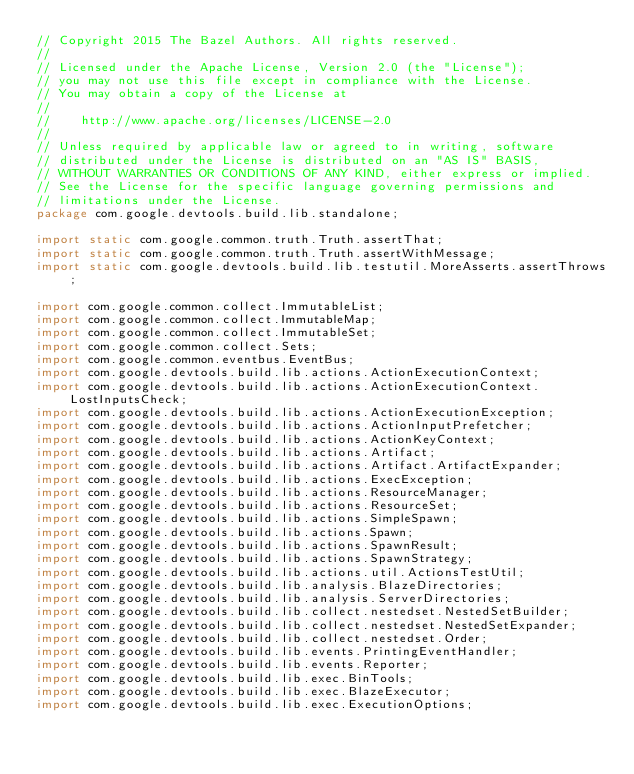Convert code to text. <code><loc_0><loc_0><loc_500><loc_500><_Java_>// Copyright 2015 The Bazel Authors. All rights reserved.
//
// Licensed under the Apache License, Version 2.0 (the "License");
// you may not use this file except in compliance with the License.
// You may obtain a copy of the License at
//
//    http://www.apache.org/licenses/LICENSE-2.0
//
// Unless required by applicable law or agreed to in writing, software
// distributed under the License is distributed on an "AS IS" BASIS,
// WITHOUT WARRANTIES OR CONDITIONS OF ANY KIND, either express or implied.
// See the License for the specific language governing permissions and
// limitations under the License.
package com.google.devtools.build.lib.standalone;

import static com.google.common.truth.Truth.assertThat;
import static com.google.common.truth.Truth.assertWithMessage;
import static com.google.devtools.build.lib.testutil.MoreAsserts.assertThrows;

import com.google.common.collect.ImmutableList;
import com.google.common.collect.ImmutableMap;
import com.google.common.collect.ImmutableSet;
import com.google.common.collect.Sets;
import com.google.common.eventbus.EventBus;
import com.google.devtools.build.lib.actions.ActionExecutionContext;
import com.google.devtools.build.lib.actions.ActionExecutionContext.LostInputsCheck;
import com.google.devtools.build.lib.actions.ActionExecutionException;
import com.google.devtools.build.lib.actions.ActionInputPrefetcher;
import com.google.devtools.build.lib.actions.ActionKeyContext;
import com.google.devtools.build.lib.actions.Artifact;
import com.google.devtools.build.lib.actions.Artifact.ArtifactExpander;
import com.google.devtools.build.lib.actions.ExecException;
import com.google.devtools.build.lib.actions.ResourceManager;
import com.google.devtools.build.lib.actions.ResourceSet;
import com.google.devtools.build.lib.actions.SimpleSpawn;
import com.google.devtools.build.lib.actions.Spawn;
import com.google.devtools.build.lib.actions.SpawnResult;
import com.google.devtools.build.lib.actions.SpawnStrategy;
import com.google.devtools.build.lib.actions.util.ActionsTestUtil;
import com.google.devtools.build.lib.analysis.BlazeDirectories;
import com.google.devtools.build.lib.analysis.ServerDirectories;
import com.google.devtools.build.lib.collect.nestedset.NestedSetBuilder;
import com.google.devtools.build.lib.collect.nestedset.NestedSetExpander;
import com.google.devtools.build.lib.collect.nestedset.Order;
import com.google.devtools.build.lib.events.PrintingEventHandler;
import com.google.devtools.build.lib.events.Reporter;
import com.google.devtools.build.lib.exec.BinTools;
import com.google.devtools.build.lib.exec.BlazeExecutor;
import com.google.devtools.build.lib.exec.ExecutionOptions;</code> 